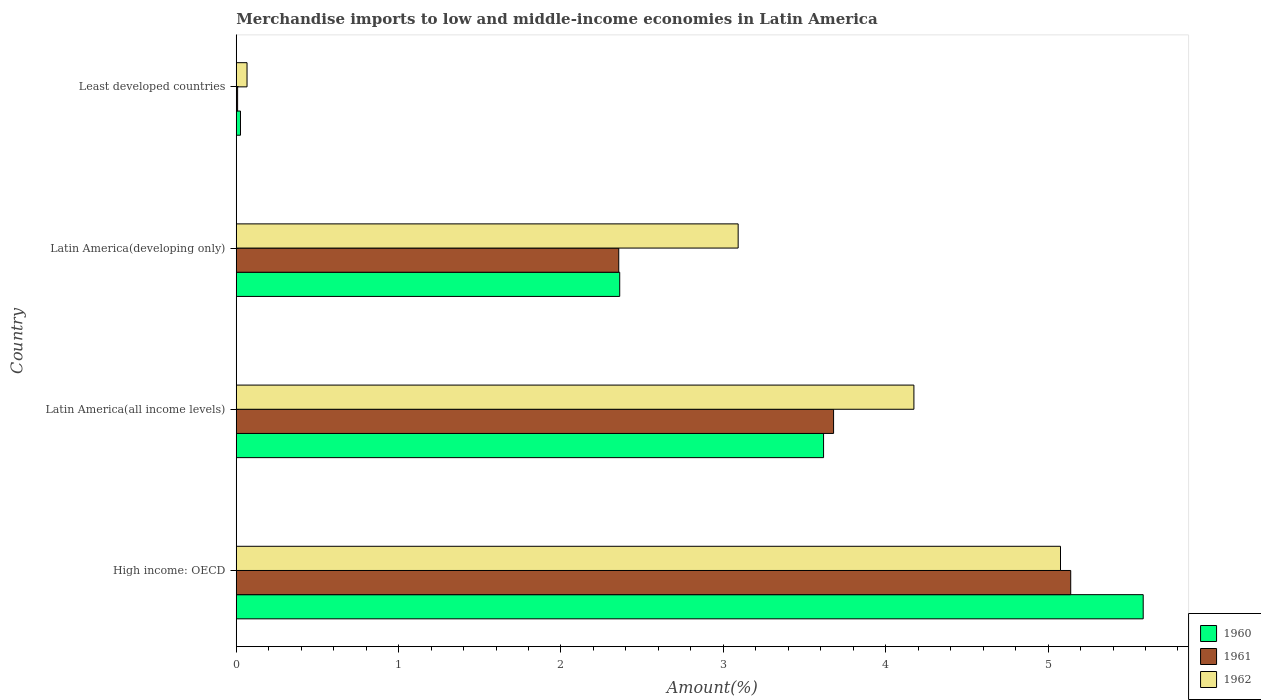How many different coloured bars are there?
Keep it short and to the point. 3. How many groups of bars are there?
Provide a succinct answer. 4. Are the number of bars on each tick of the Y-axis equal?
Your response must be concise. Yes. How many bars are there on the 3rd tick from the top?
Provide a short and direct response. 3. What is the label of the 3rd group of bars from the top?
Provide a short and direct response. Latin America(all income levels). What is the percentage of amount earned from merchandise imports in 1960 in High income: OECD?
Provide a short and direct response. 5.59. Across all countries, what is the maximum percentage of amount earned from merchandise imports in 1960?
Your response must be concise. 5.59. Across all countries, what is the minimum percentage of amount earned from merchandise imports in 1961?
Your answer should be very brief. 0.01. In which country was the percentage of amount earned from merchandise imports in 1961 maximum?
Your answer should be compact. High income: OECD. In which country was the percentage of amount earned from merchandise imports in 1961 minimum?
Make the answer very short. Least developed countries. What is the total percentage of amount earned from merchandise imports in 1961 in the graph?
Give a very brief answer. 11.18. What is the difference between the percentage of amount earned from merchandise imports in 1960 in High income: OECD and that in Latin America(developing only)?
Your answer should be compact. 3.22. What is the difference between the percentage of amount earned from merchandise imports in 1960 in Latin America(all income levels) and the percentage of amount earned from merchandise imports in 1961 in Least developed countries?
Your answer should be compact. 3.61. What is the average percentage of amount earned from merchandise imports in 1961 per country?
Make the answer very short. 2.8. What is the difference between the percentage of amount earned from merchandise imports in 1962 and percentage of amount earned from merchandise imports in 1960 in Latin America(developing only)?
Offer a terse response. 0.73. In how many countries, is the percentage of amount earned from merchandise imports in 1962 greater than 5.4 %?
Keep it short and to the point. 0. What is the ratio of the percentage of amount earned from merchandise imports in 1960 in High income: OECD to that in Latin America(all income levels)?
Your answer should be very brief. 1.54. Is the percentage of amount earned from merchandise imports in 1962 in Latin America(all income levels) less than that in Least developed countries?
Provide a short and direct response. No. What is the difference between the highest and the second highest percentage of amount earned from merchandise imports in 1962?
Give a very brief answer. 0.9. What is the difference between the highest and the lowest percentage of amount earned from merchandise imports in 1962?
Offer a very short reply. 5.01. In how many countries, is the percentage of amount earned from merchandise imports in 1962 greater than the average percentage of amount earned from merchandise imports in 1962 taken over all countries?
Give a very brief answer. 2. Is the sum of the percentage of amount earned from merchandise imports in 1961 in High income: OECD and Latin America(developing only) greater than the maximum percentage of amount earned from merchandise imports in 1960 across all countries?
Provide a succinct answer. Yes. Is it the case that in every country, the sum of the percentage of amount earned from merchandise imports in 1961 and percentage of amount earned from merchandise imports in 1960 is greater than the percentage of amount earned from merchandise imports in 1962?
Your response must be concise. No. How many bars are there?
Keep it short and to the point. 12. Are all the bars in the graph horizontal?
Offer a very short reply. Yes. What is the difference between two consecutive major ticks on the X-axis?
Give a very brief answer. 1. Are the values on the major ticks of X-axis written in scientific E-notation?
Make the answer very short. No. Where does the legend appear in the graph?
Your response must be concise. Bottom right. How many legend labels are there?
Keep it short and to the point. 3. What is the title of the graph?
Ensure brevity in your answer.  Merchandise imports to low and middle-income economies in Latin America. What is the label or title of the X-axis?
Your answer should be very brief. Amount(%). What is the label or title of the Y-axis?
Give a very brief answer. Country. What is the Amount(%) in 1960 in High income: OECD?
Offer a very short reply. 5.59. What is the Amount(%) in 1961 in High income: OECD?
Provide a succinct answer. 5.14. What is the Amount(%) in 1962 in High income: OECD?
Your answer should be very brief. 5.08. What is the Amount(%) in 1960 in Latin America(all income levels)?
Your answer should be very brief. 3.62. What is the Amount(%) of 1961 in Latin America(all income levels)?
Give a very brief answer. 3.68. What is the Amount(%) in 1962 in Latin America(all income levels)?
Offer a terse response. 4.17. What is the Amount(%) in 1960 in Latin America(developing only)?
Provide a short and direct response. 2.36. What is the Amount(%) of 1961 in Latin America(developing only)?
Your answer should be compact. 2.36. What is the Amount(%) of 1962 in Latin America(developing only)?
Give a very brief answer. 3.09. What is the Amount(%) of 1960 in Least developed countries?
Ensure brevity in your answer.  0.03. What is the Amount(%) of 1961 in Least developed countries?
Provide a short and direct response. 0.01. What is the Amount(%) of 1962 in Least developed countries?
Offer a very short reply. 0.07. Across all countries, what is the maximum Amount(%) in 1960?
Offer a terse response. 5.59. Across all countries, what is the maximum Amount(%) of 1961?
Give a very brief answer. 5.14. Across all countries, what is the maximum Amount(%) of 1962?
Provide a succinct answer. 5.08. Across all countries, what is the minimum Amount(%) in 1960?
Your answer should be very brief. 0.03. Across all countries, what is the minimum Amount(%) in 1961?
Your response must be concise. 0.01. Across all countries, what is the minimum Amount(%) in 1962?
Your answer should be compact. 0.07. What is the total Amount(%) of 1960 in the graph?
Your answer should be very brief. 11.59. What is the total Amount(%) in 1961 in the graph?
Your response must be concise. 11.18. What is the total Amount(%) in 1962 in the graph?
Provide a short and direct response. 12.41. What is the difference between the Amount(%) of 1960 in High income: OECD and that in Latin America(all income levels)?
Make the answer very short. 1.97. What is the difference between the Amount(%) of 1961 in High income: OECD and that in Latin America(all income levels)?
Offer a terse response. 1.46. What is the difference between the Amount(%) in 1962 in High income: OECD and that in Latin America(all income levels)?
Keep it short and to the point. 0.9. What is the difference between the Amount(%) of 1960 in High income: OECD and that in Latin America(developing only)?
Offer a very short reply. 3.22. What is the difference between the Amount(%) of 1961 in High income: OECD and that in Latin America(developing only)?
Your answer should be very brief. 2.78. What is the difference between the Amount(%) in 1962 in High income: OECD and that in Latin America(developing only)?
Make the answer very short. 1.99. What is the difference between the Amount(%) in 1960 in High income: OECD and that in Least developed countries?
Provide a short and direct response. 5.56. What is the difference between the Amount(%) in 1961 in High income: OECD and that in Least developed countries?
Offer a very short reply. 5.13. What is the difference between the Amount(%) of 1962 in High income: OECD and that in Least developed countries?
Ensure brevity in your answer.  5.01. What is the difference between the Amount(%) of 1960 in Latin America(all income levels) and that in Latin America(developing only)?
Make the answer very short. 1.26. What is the difference between the Amount(%) of 1961 in Latin America(all income levels) and that in Latin America(developing only)?
Provide a succinct answer. 1.32. What is the difference between the Amount(%) of 1962 in Latin America(all income levels) and that in Latin America(developing only)?
Ensure brevity in your answer.  1.08. What is the difference between the Amount(%) of 1960 in Latin America(all income levels) and that in Least developed countries?
Keep it short and to the point. 3.59. What is the difference between the Amount(%) of 1961 in Latin America(all income levels) and that in Least developed countries?
Offer a very short reply. 3.67. What is the difference between the Amount(%) of 1962 in Latin America(all income levels) and that in Least developed countries?
Offer a terse response. 4.11. What is the difference between the Amount(%) in 1960 in Latin America(developing only) and that in Least developed countries?
Give a very brief answer. 2.34. What is the difference between the Amount(%) in 1961 in Latin America(developing only) and that in Least developed countries?
Ensure brevity in your answer.  2.35. What is the difference between the Amount(%) in 1962 in Latin America(developing only) and that in Least developed countries?
Keep it short and to the point. 3.02. What is the difference between the Amount(%) of 1960 in High income: OECD and the Amount(%) of 1961 in Latin America(all income levels)?
Keep it short and to the point. 1.91. What is the difference between the Amount(%) in 1960 in High income: OECD and the Amount(%) in 1962 in Latin America(all income levels)?
Offer a terse response. 1.41. What is the difference between the Amount(%) of 1961 in High income: OECD and the Amount(%) of 1962 in Latin America(all income levels)?
Offer a very short reply. 0.97. What is the difference between the Amount(%) of 1960 in High income: OECD and the Amount(%) of 1961 in Latin America(developing only)?
Make the answer very short. 3.23. What is the difference between the Amount(%) in 1960 in High income: OECD and the Amount(%) in 1962 in Latin America(developing only)?
Provide a succinct answer. 2.49. What is the difference between the Amount(%) of 1961 in High income: OECD and the Amount(%) of 1962 in Latin America(developing only)?
Give a very brief answer. 2.05. What is the difference between the Amount(%) in 1960 in High income: OECD and the Amount(%) in 1961 in Least developed countries?
Make the answer very short. 5.58. What is the difference between the Amount(%) of 1960 in High income: OECD and the Amount(%) of 1962 in Least developed countries?
Offer a very short reply. 5.52. What is the difference between the Amount(%) in 1961 in High income: OECD and the Amount(%) in 1962 in Least developed countries?
Ensure brevity in your answer.  5.07. What is the difference between the Amount(%) in 1960 in Latin America(all income levels) and the Amount(%) in 1961 in Latin America(developing only)?
Keep it short and to the point. 1.26. What is the difference between the Amount(%) of 1960 in Latin America(all income levels) and the Amount(%) of 1962 in Latin America(developing only)?
Provide a succinct answer. 0.53. What is the difference between the Amount(%) of 1961 in Latin America(all income levels) and the Amount(%) of 1962 in Latin America(developing only)?
Make the answer very short. 0.59. What is the difference between the Amount(%) in 1960 in Latin America(all income levels) and the Amount(%) in 1961 in Least developed countries?
Make the answer very short. 3.61. What is the difference between the Amount(%) in 1960 in Latin America(all income levels) and the Amount(%) in 1962 in Least developed countries?
Keep it short and to the point. 3.55. What is the difference between the Amount(%) of 1961 in Latin America(all income levels) and the Amount(%) of 1962 in Least developed countries?
Make the answer very short. 3.61. What is the difference between the Amount(%) in 1960 in Latin America(developing only) and the Amount(%) in 1961 in Least developed countries?
Provide a short and direct response. 2.35. What is the difference between the Amount(%) in 1960 in Latin America(developing only) and the Amount(%) in 1962 in Least developed countries?
Give a very brief answer. 2.3. What is the difference between the Amount(%) of 1961 in Latin America(developing only) and the Amount(%) of 1962 in Least developed countries?
Your response must be concise. 2.29. What is the average Amount(%) in 1960 per country?
Offer a very short reply. 2.9. What is the average Amount(%) in 1961 per country?
Provide a succinct answer. 2.8. What is the average Amount(%) of 1962 per country?
Give a very brief answer. 3.1. What is the difference between the Amount(%) of 1960 and Amount(%) of 1961 in High income: OECD?
Provide a succinct answer. 0.45. What is the difference between the Amount(%) in 1960 and Amount(%) in 1962 in High income: OECD?
Your answer should be compact. 0.51. What is the difference between the Amount(%) of 1961 and Amount(%) of 1962 in High income: OECD?
Your response must be concise. 0.06. What is the difference between the Amount(%) in 1960 and Amount(%) in 1961 in Latin America(all income levels)?
Your answer should be very brief. -0.06. What is the difference between the Amount(%) in 1960 and Amount(%) in 1962 in Latin America(all income levels)?
Provide a succinct answer. -0.56. What is the difference between the Amount(%) of 1961 and Amount(%) of 1962 in Latin America(all income levels)?
Provide a succinct answer. -0.49. What is the difference between the Amount(%) in 1960 and Amount(%) in 1961 in Latin America(developing only)?
Provide a succinct answer. 0.01. What is the difference between the Amount(%) of 1960 and Amount(%) of 1962 in Latin America(developing only)?
Provide a short and direct response. -0.73. What is the difference between the Amount(%) in 1961 and Amount(%) in 1962 in Latin America(developing only)?
Offer a very short reply. -0.74. What is the difference between the Amount(%) of 1960 and Amount(%) of 1961 in Least developed countries?
Ensure brevity in your answer.  0.02. What is the difference between the Amount(%) of 1960 and Amount(%) of 1962 in Least developed countries?
Provide a short and direct response. -0.04. What is the difference between the Amount(%) in 1961 and Amount(%) in 1962 in Least developed countries?
Offer a terse response. -0.06. What is the ratio of the Amount(%) in 1960 in High income: OECD to that in Latin America(all income levels)?
Make the answer very short. 1.54. What is the ratio of the Amount(%) of 1961 in High income: OECD to that in Latin America(all income levels)?
Your answer should be very brief. 1.4. What is the ratio of the Amount(%) in 1962 in High income: OECD to that in Latin America(all income levels)?
Provide a short and direct response. 1.22. What is the ratio of the Amount(%) of 1960 in High income: OECD to that in Latin America(developing only)?
Offer a terse response. 2.37. What is the ratio of the Amount(%) in 1961 in High income: OECD to that in Latin America(developing only)?
Provide a succinct answer. 2.18. What is the ratio of the Amount(%) of 1962 in High income: OECD to that in Latin America(developing only)?
Give a very brief answer. 1.64. What is the ratio of the Amount(%) in 1960 in High income: OECD to that in Least developed countries?
Your response must be concise. 214.16. What is the ratio of the Amount(%) in 1961 in High income: OECD to that in Least developed countries?
Make the answer very short. 616.57. What is the ratio of the Amount(%) of 1962 in High income: OECD to that in Least developed countries?
Ensure brevity in your answer.  76.49. What is the ratio of the Amount(%) in 1960 in Latin America(all income levels) to that in Latin America(developing only)?
Offer a terse response. 1.53. What is the ratio of the Amount(%) in 1961 in Latin America(all income levels) to that in Latin America(developing only)?
Your answer should be very brief. 1.56. What is the ratio of the Amount(%) of 1962 in Latin America(all income levels) to that in Latin America(developing only)?
Offer a very short reply. 1.35. What is the ratio of the Amount(%) of 1960 in Latin America(all income levels) to that in Least developed countries?
Keep it short and to the point. 138.68. What is the ratio of the Amount(%) in 1961 in Latin America(all income levels) to that in Least developed countries?
Provide a short and direct response. 441.35. What is the ratio of the Amount(%) of 1962 in Latin America(all income levels) to that in Least developed countries?
Give a very brief answer. 62.89. What is the ratio of the Amount(%) of 1960 in Latin America(developing only) to that in Least developed countries?
Make the answer very short. 90.55. What is the ratio of the Amount(%) in 1961 in Latin America(developing only) to that in Least developed countries?
Your response must be concise. 282.62. What is the ratio of the Amount(%) of 1962 in Latin America(developing only) to that in Least developed countries?
Provide a succinct answer. 46.58. What is the difference between the highest and the second highest Amount(%) of 1960?
Offer a very short reply. 1.97. What is the difference between the highest and the second highest Amount(%) of 1961?
Give a very brief answer. 1.46. What is the difference between the highest and the second highest Amount(%) of 1962?
Make the answer very short. 0.9. What is the difference between the highest and the lowest Amount(%) in 1960?
Your response must be concise. 5.56. What is the difference between the highest and the lowest Amount(%) in 1961?
Ensure brevity in your answer.  5.13. What is the difference between the highest and the lowest Amount(%) of 1962?
Keep it short and to the point. 5.01. 